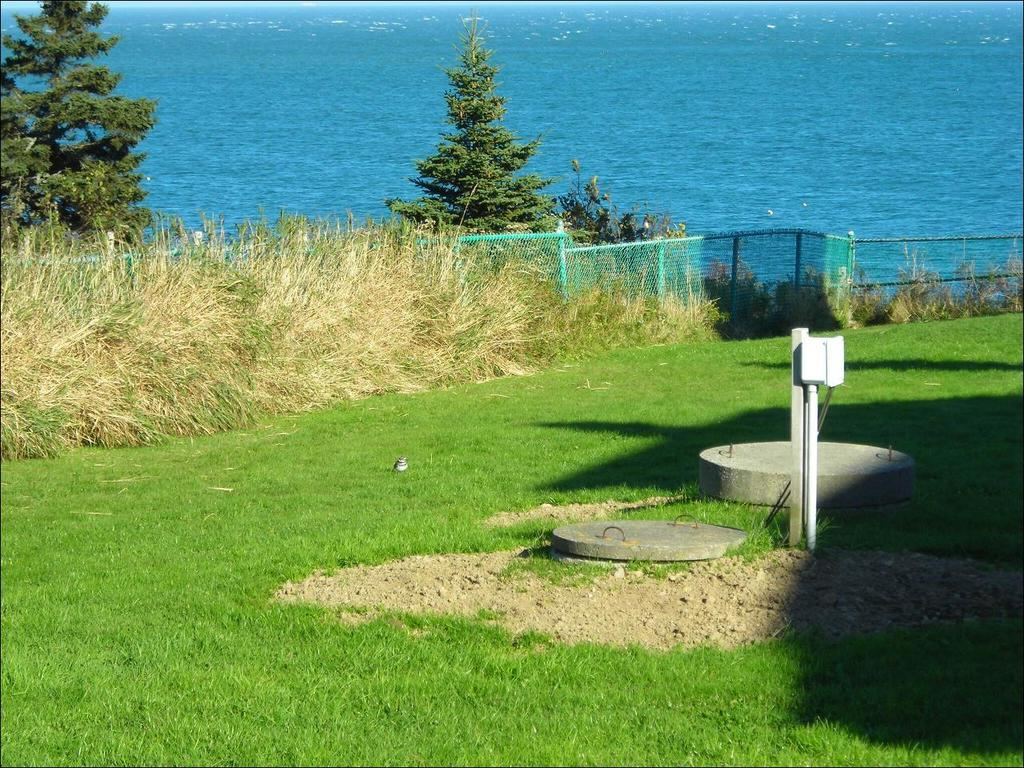What type of vegetation can be seen in the image? There is grass in the image. What type of structure is present in the image? There is a fence in the image. What other object can be seen in the image? There is a pole in the image. What type of coverings are present in the image? There are concrete lids in the image. What type of natural elements are present in the image? There are trees in the image. What else can be seen in the image? There are some objects in the image. What can be seen in the background of the image? There is water visible in the background of the image. How does the wire affect the lock in the image? There is no wire or lock present in the image. What type of loss is depicted in the image? There is no loss depicted in the image; it features grass, a fence, a pole, concrete lids, trees, objects, and water in the background. 